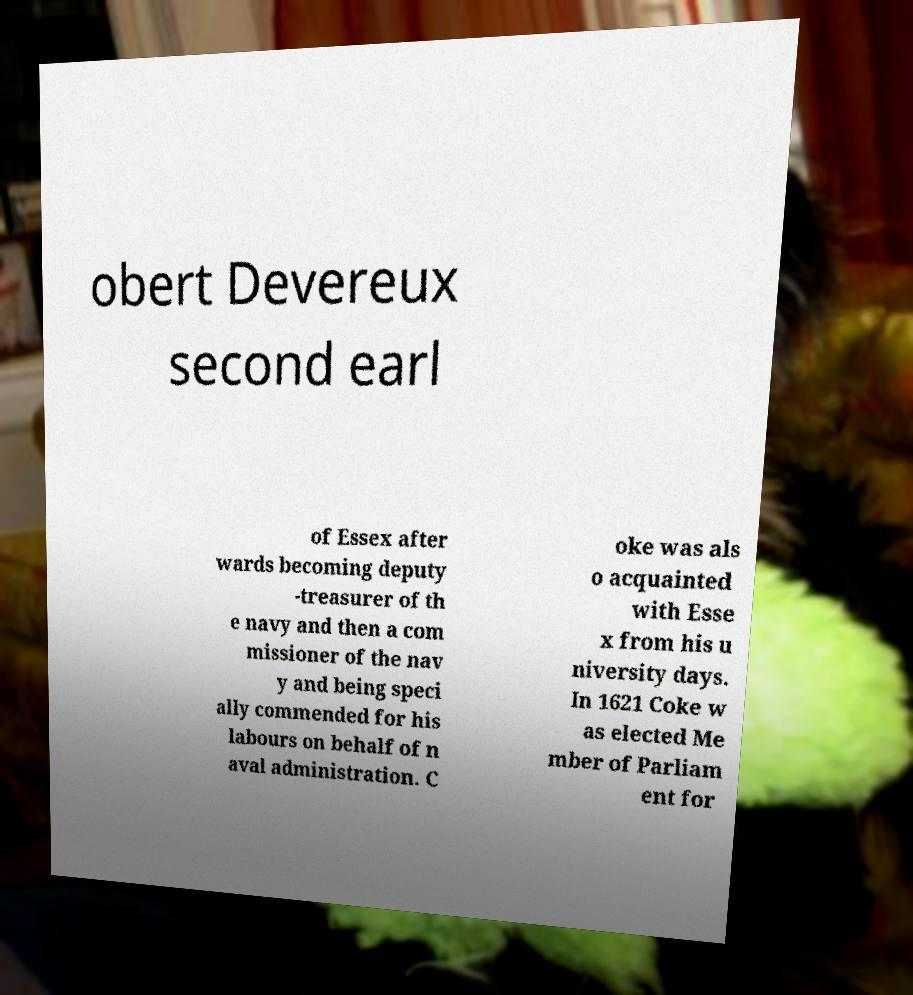Could you extract and type out the text from this image? obert Devereux second earl of Essex after wards becoming deputy -treasurer of th e navy and then a com missioner of the nav y and being speci ally commended for his labours on behalf of n aval administration. C oke was als o acquainted with Esse x from his u niversity days. In 1621 Coke w as elected Me mber of Parliam ent for 